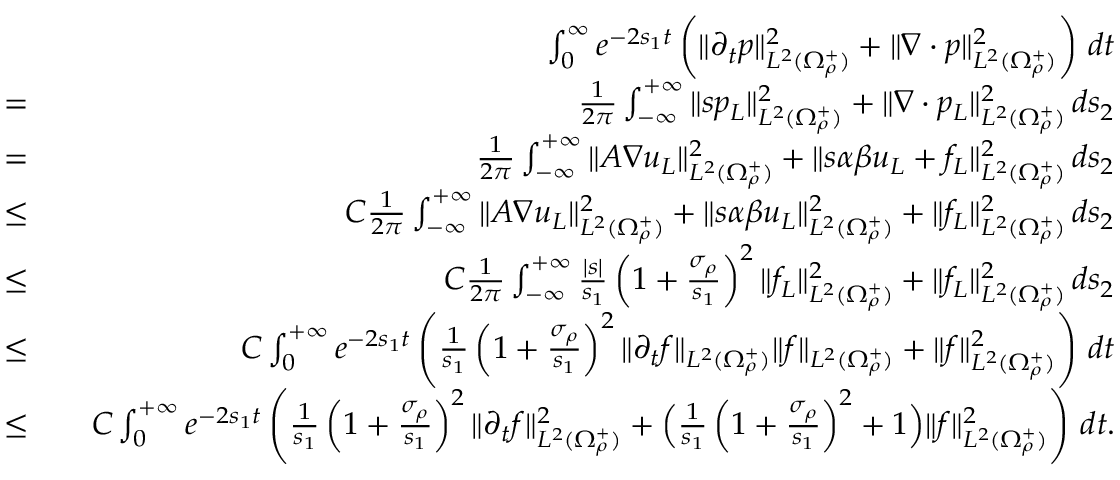<formula> <loc_0><loc_0><loc_500><loc_500>\begin{array} { r l r } & { \int _ { 0 } ^ { \infty } e ^ { - 2 s _ { 1 } t } \left ( \| \partial _ { t } p \| _ { L ^ { 2 } ( \Omega _ { \rho } ^ { + } ) } ^ { 2 } + \| \nabla \cdot p \| _ { L ^ { 2 } ( \Omega _ { \rho } ^ { + } ) } ^ { 2 } \right ) \, d t } \\ { = } & { \frac { 1 } { 2 \pi } \int _ { - \infty } ^ { + \infty } \| s p _ { L } \| _ { L ^ { 2 } ( \Omega _ { \rho } ^ { + } ) } ^ { 2 } + \| \nabla \cdot p _ { L } \| _ { L ^ { 2 } ( \Omega _ { \rho } ^ { + } ) } ^ { 2 } \, d s _ { 2 } } \\ { = } & { \frac { 1 } { 2 \pi } \int _ { - \infty } ^ { + \infty } \| A \nabla u _ { L } \| _ { L ^ { 2 } ( \Omega _ { \rho } ^ { + } ) } ^ { 2 } + \| s \alpha \beta u _ { L } + f _ { L } \| _ { L ^ { 2 } ( \Omega _ { \rho } ^ { + } ) } ^ { 2 } \, d s _ { 2 } } \\ { \leq } & { C \frac { 1 } { 2 \pi } \int _ { - \infty } ^ { + \infty } \| A \nabla u _ { L } \| _ { L ^ { 2 } ( \Omega _ { \rho } ^ { + } ) } ^ { 2 } + \| s \alpha \beta u _ { L } \| _ { L ^ { 2 } ( \Omega _ { \rho } ^ { + } ) } ^ { 2 } + \| f _ { L } \| _ { L ^ { 2 } ( \Omega _ { \rho } ^ { + } ) } ^ { 2 } \, d s _ { 2 } } \\ { \leq } & { C \frac { 1 } { 2 \pi } \int _ { - \infty } ^ { + \infty } \frac { | s | } { s _ { 1 } } \left ( 1 + \frac { \sigma _ { \rho } } { s _ { 1 } } \right ) ^ { 2 } \| f _ { L } \| _ { L ^ { 2 } ( \Omega _ { \rho } ^ { + } ) } ^ { 2 } + \| f _ { L } \| _ { L ^ { 2 } ( \Omega _ { \rho } ^ { + } ) } ^ { 2 } \, d s _ { 2 } } \\ { \leq } & { C \int _ { 0 } ^ { + \infty } e ^ { - 2 s _ { 1 } t } \left ( \frac { 1 } { s _ { 1 } } \left ( 1 + \frac { \sigma _ { \rho } } { s _ { 1 } } \right ) ^ { 2 } \| \partial _ { t } f \| _ { L ^ { 2 } ( \Omega _ { \rho } ^ { + } ) } \| f \| _ { L ^ { 2 } ( \Omega _ { \rho } ^ { + } ) } + \| f \| _ { L ^ { 2 } ( \Omega _ { \rho } ^ { + } ) } ^ { 2 } \right ) \, d t } \\ { \leq } & { C \int _ { 0 } ^ { + \infty } e ^ { - 2 s _ { 1 } t } \left ( \frac { 1 } { s _ { 1 } } \left ( 1 + \frac { \sigma _ { \rho } } { s _ { 1 } } \right ) ^ { 2 } \| \partial _ { t } f \| _ { L ^ { 2 } ( \Omega _ { \rho } ^ { + } ) } ^ { 2 } + \left ( \frac { 1 } { s _ { 1 } } \left ( 1 + \frac { \sigma _ { \rho } } { s _ { 1 } } \right ) ^ { 2 } + 1 \right ) \| f \| _ { L ^ { 2 } ( \Omega _ { \rho } ^ { + } ) } ^ { 2 } \right ) \, d t . } \end{array}</formula> 